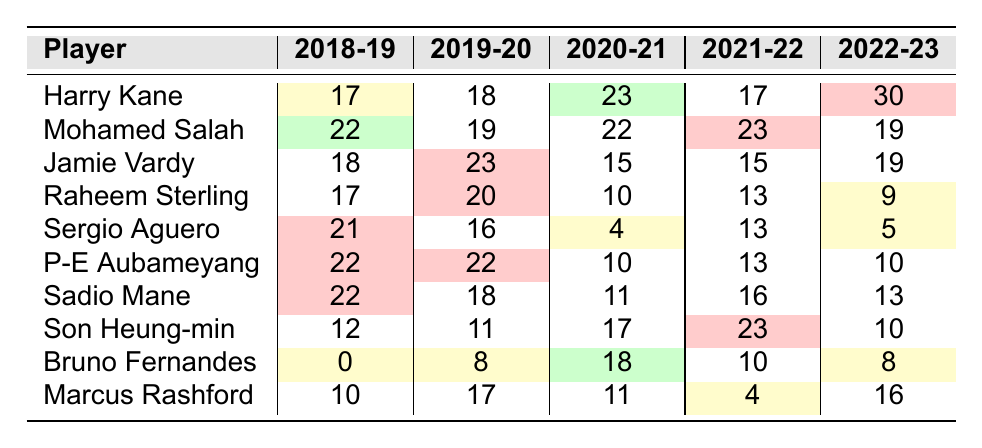What was Harry Kane's highest goal tally in a single season? By examining the data in the table, Harry Kane had his highest goal tally in the 2022-23 season, where he scored 30 goals.
Answer: 30 In how many seasons did Mohamed Salah score more than 20 goals? Looking at Mohamed Salah's goal tallies, he scored more than 20 goals in three seasons: 2018-19, 2020-21, and 2021-22.
Answer: 3 Which player had the lowest number of goals in a single season? Checking the table, Bruno Fernandes scored 0 goals in the 2018-19 season, which is the lowest among all players listed.
Answer: 0 What is the average number of goals scored by Son Heung-min over the five seasons? To find the average, sum Son Heung-min's goals: 12 + 11 + 17 + 23 + 10 = 73. Then divide by 5 (the number of seasons): 73 / 5 = 14.6.
Answer: 14.6 Did Sergio Aguero ever score less than 10 goals in a season? Reviewing the table, Sergio Aguero scored less than 10 goals in the 2020-21 and 2022-23 seasons, where he scored 4 and 5 goals, respectively.
Answer: Yes What was the total number of goals scored by Raheem Sterling during the last five seasons? Raheem Sterling's total goals are calculated as follows: 17 + 20 + 10 + 13 + 9 = 69. Therefore, his total is 69 goals.
Answer: 69 Which player had the most consistent scoring across all seasons, with little variation in goals? By analyzing the table, Pierre-Emerick Aubameyang scored consistently with 22, 22, 10, 13, and 10 goals. The score of 10 is the only significant drop compared to his other scores.
Answer: Pierre-Emerick Aubameyang What is the difference between the highest and lowest goal tallies scored by Jamie Vardy in the past five seasons? Jamie Vardy's highest was 23 goals in the 2019-20 season and his lowest was 15 goals in both the 2020-21 and 2021-22 seasons. The difference is 23 - 15 = 8.
Answer: 8 Which player showed a significant decline in performance from 2019-20 to 2020-21? If we observe the table, Raheem Sterling's goals dropped from 20 in 2019-20 to 10 in 2020-21, showing a significant decline of 10 goals.
Answer: Raheem Sterling Who scored the least amount of goals in the 2022-23 season? In 2022-23, Raheem Sterling scored 9 goals and Sergio Aguero scored only 5 goals, making Aguero the player with the least amount of goals that season.
Answer: Sergio Aguero 